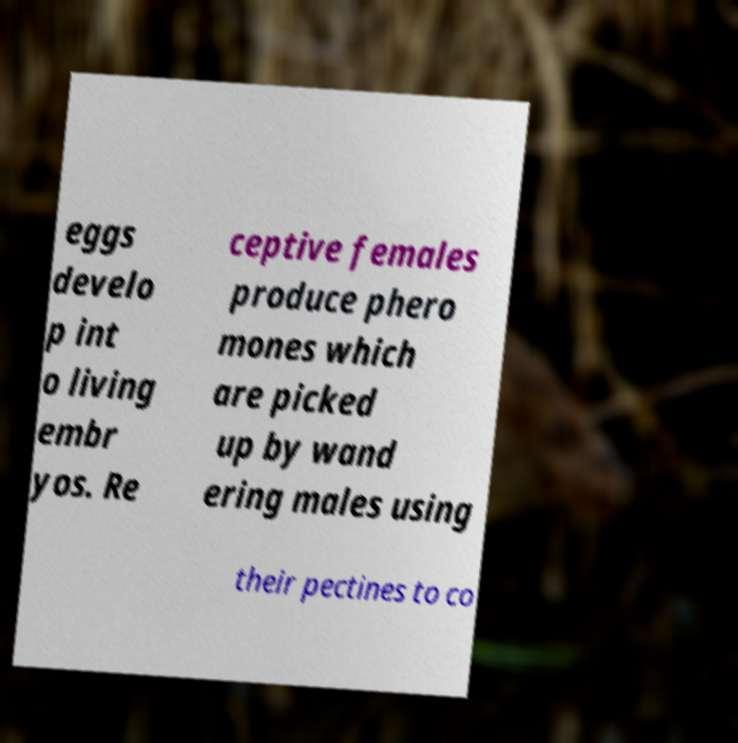There's text embedded in this image that I need extracted. Can you transcribe it verbatim? eggs develo p int o living embr yos. Re ceptive females produce phero mones which are picked up by wand ering males using their pectines to co 